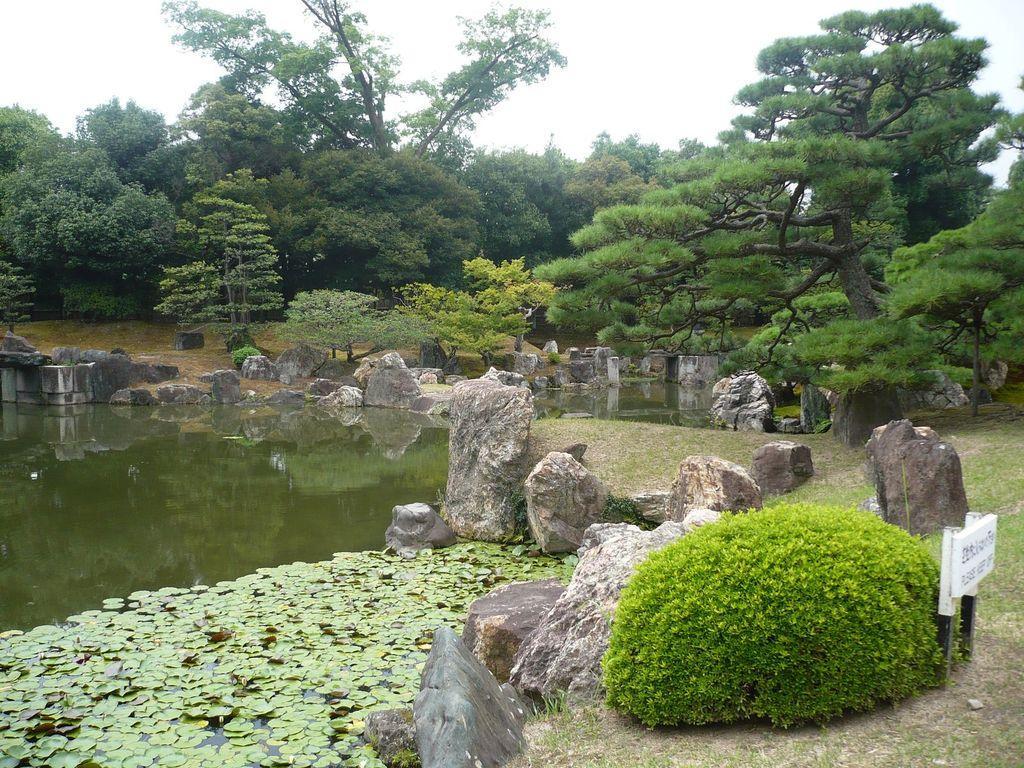In one or two sentences, can you explain what this image depicts? In the center of the image we can see the sky,clouds,trees,plants,grass,water,stones,one sign board etc. 